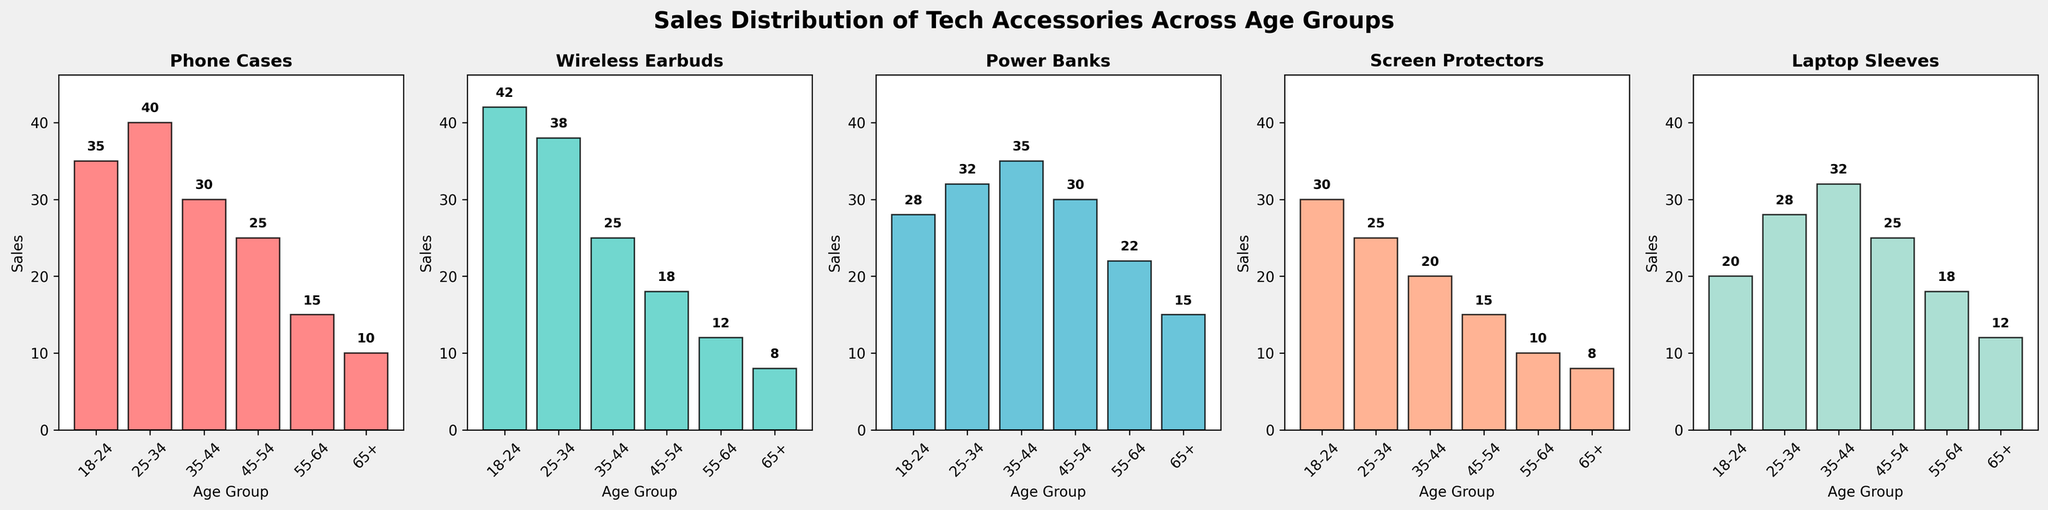Which age group has the highest sales of wireless earbuds? By looking at the subplot for wireless earbuds, we can compare the heights of the bars for each age group. The age group 18-24 has the highest bar.
Answer: 18-24 Between age groups 25-34 and 35-44, which one has more power bank sales, and by how much? Compare the heights of the bars in the power bank subplot for the age groups 25-34 and 35-44. The sales for 25-34 are 32 units, and for 35-44 are 35 units. The difference is 35 - 32 = 3 units.
Answer: 35-44 by 3 units What is the total sales for laptop sleeves among all age groups? Sum up the sales values for laptop sleeves across all age groups: 20 (18-24) + 28 (25-34) + 32 (35-44) + 25 (45-54) + 18 (55-64) + 12 (65+). The total is 20 + 28 + 32 + 25 + 18 + 12 = 135.
Answer: 135 Which accessory has the lowest sales in the 45-54 age group? By observing the subplot for the 45-54 age group and comparing the heights of the bars, the sales numbers are: Phone Cases (25), Wireless Earbuds (18), Power Banks (30), Screen Protectors (15), and Laptop Sleeves (25). The lowest sales value is for Screen Protectors.
Answer: Screen Protectors What is the average sales of phone cases across all age groups? Calculate the average of the sales for phone cases across all age groups: (35 + 40 + 30 + 25 + 15 + 10) / 6. The sum is 35 + 40 + 30 + 25 + 15 + 10 = 155. The average is 155 / 6 ≈ 25.83.
Answer: Approximately 25.83 For the 18-24 age group, which accessory has the greatest difference in sales compared to the 65+ age group? Compare the sales of each accessory between the 18-24 and 65+ age groups and find the maximum difference. Phone Cases: 35 - 10 = 25, Wireless Earbuds: 42 - 8 = 34, Power Banks: 28 - 15 = 13, Screen Protectors: 30 - 8 = 22, Laptop Sleeves: 20 - 12 = 8. The greatest difference is for Wireless Earbuds with a difference of 34.
Answer: Wireless Earbuds Which accessory has the most even distribution of sales across the different age groups based on the visual observation? By visually comparing the subplots, the accessory with bars that appear the most similar in height is the Screen Protectors, suggesting a more even distribution of sales across age groups.
Answer: Screen Protectors How do the sales of screen protectors in the 25-34 and 55-64 age groups compare? Observe the heights of the bars in the Screen Protectors subplot for the 25-34 and 55-64 age groups. The sales for 25-34 are 25 units, and for 55-64 are 10 units. Therefore, 25-34 age group has higher sales.
Answer: 25-34 age group has higher sales What is the median sales value across all age groups for the accessory with the least total sales? First, determine the total sales for each accessory: Phone Cases (155), Wireless Earbuds (143), Power Banks (162), Screen Protectors (108), Laptop Sleeves (135). The accessory with least total sales is Screen Protectors. The sales data for Screen Protectors is: 30 (18-24), 25 (25-34), 20 (35-44), 15 (45-54), 10 (55-64), 8 (65+). The median value is the average of the third and fourth values when sorted: (20 + 15) / 2 = 17.5.
Answer: 17.5 